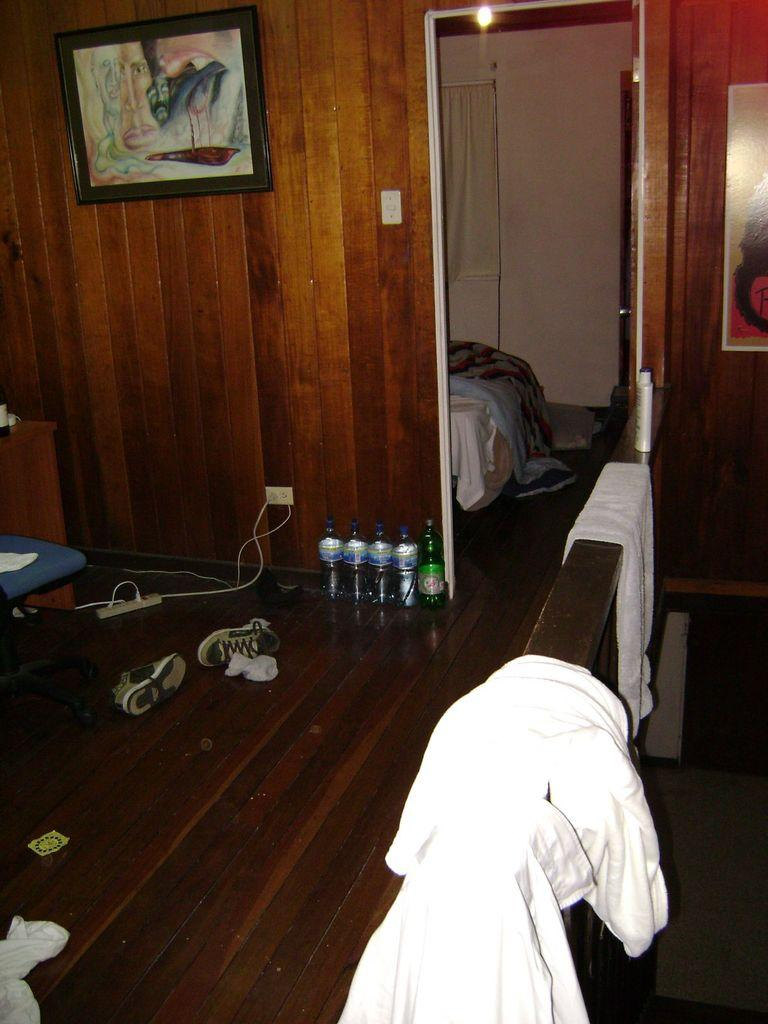What type of wall is visible in the image? There is a wooden wall in the image. What is hanging on the wall in the image? There is a photo frame hanging on the wall in the image. What type of furniture is present in the image? There is a bed in the image. What is covering the bed in the image? There is a bed sheet on the bed. What type of items can be seen on the bed? There are bottles on the bed. What type of footwear is visible in the image? There are shoes in the image. What type of electrical fixture is present in the image? There is a switch board in the image. How does the wall adjust its position in the image? The wall does not adjust its position in the image; it is a stationary structure. What type of wall is used for the adjustment in the image? There is no adjustment or wall used for adjustment in the image. 